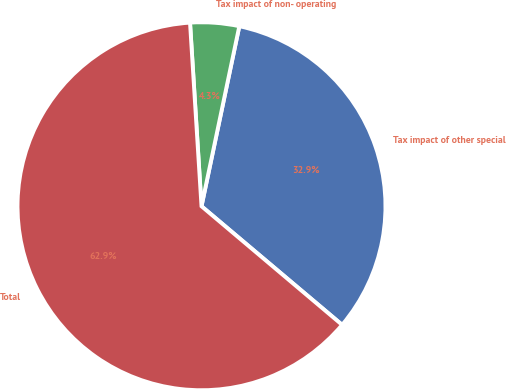<chart> <loc_0><loc_0><loc_500><loc_500><pie_chart><fcel>Tax impact of other special<fcel>Tax impact of non- operating<fcel>Total<nl><fcel>32.86%<fcel>4.29%<fcel>62.86%<nl></chart> 